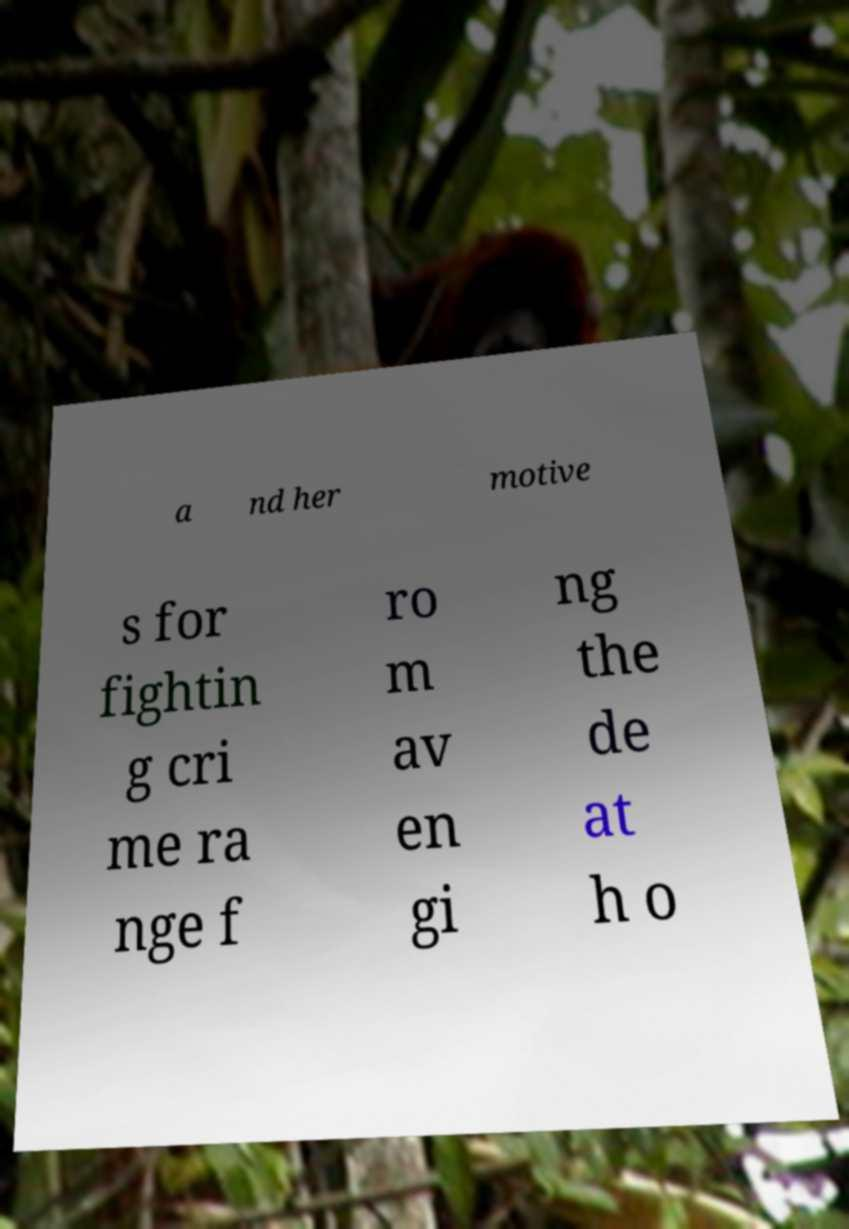Could you extract and type out the text from this image? a nd her motive s for fightin g cri me ra nge f ro m av en gi ng the de at h o 